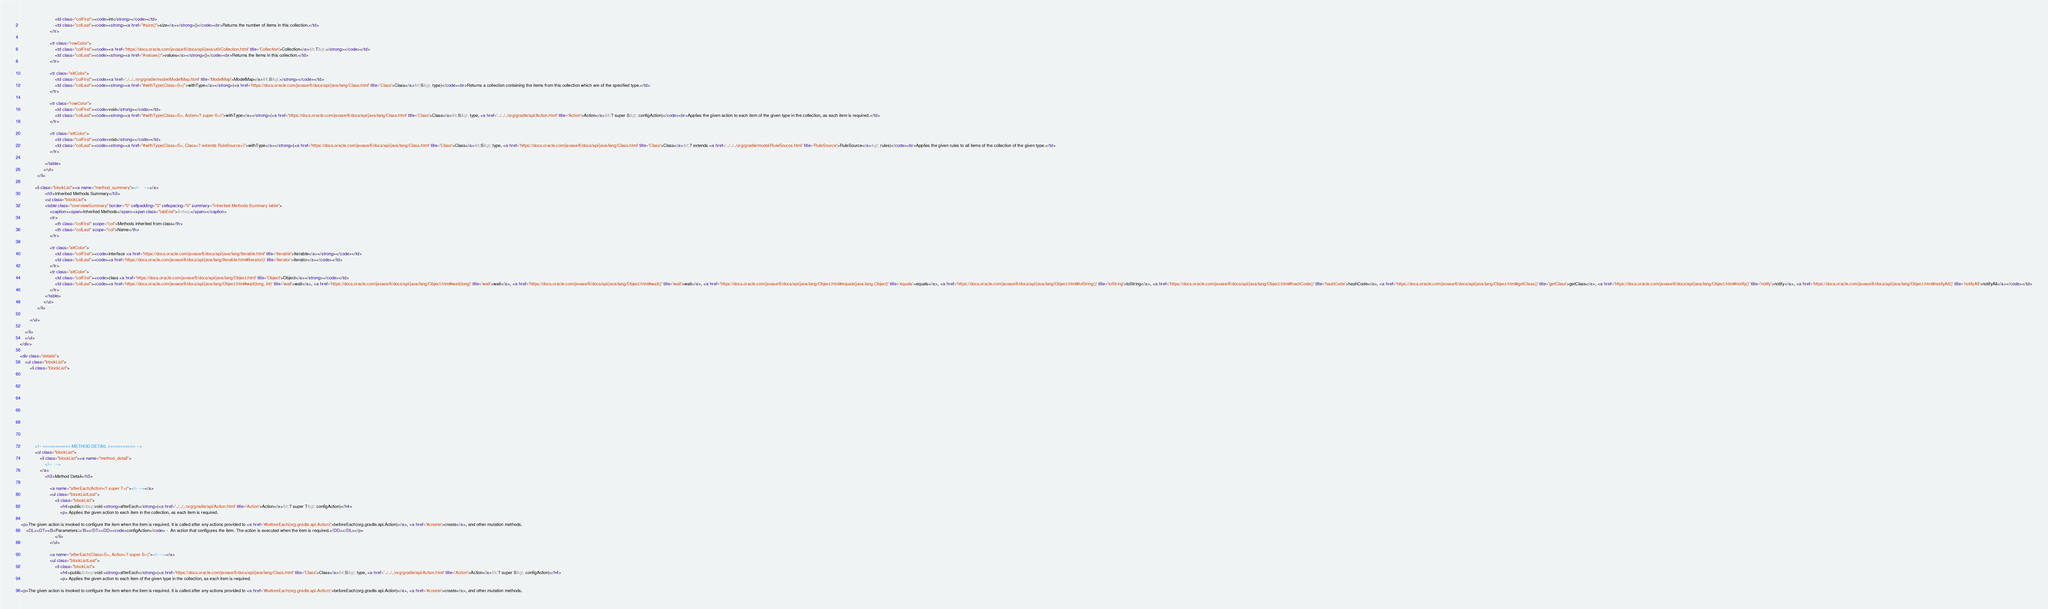<code> <loc_0><loc_0><loc_500><loc_500><_HTML_>                            <td class="colFirst"><code>int</strong></code></td>
                            <td class="colLast"><code><strong><a href="#size()">size</a></strong>()</code><br>Returns the number of items in this collection.</td>
                        </tr>
                        
                        <tr class="rowColor">
                            <td class="colFirst"><code><a href='https://docs.oracle.com/javase/6/docs/api/java/util/Collection.html' title='Collection'>Collection</a>&lt;T&gt;</strong></code></td>
                            <td class="colLast"><code><strong><a href="#values()">values</a></strong>()</code><br>Returns the items in this collection.</td>
                        </tr>
                        
                        <tr class="altColor">
                            <td class="colFirst"><code><a href='../../../org/gradle/model/ModelMap.html' title='ModelMap'>ModelMap</a>&lt;S&gt;</strong></code></td>
                            <td class="colLast"><code><strong><a href="#withType(Class<S>)">withType</a></strong>(<a href='https://docs.oracle.com/javase/6/docs/api/java/lang/Class.html' title='Class'>Class</a>&lt;S&gt; type)</code><br>Returns a collection containing the items from this collection which are of the specified type.</td>
                        </tr>
                        
                        <tr class="rowColor">
                            <td class="colFirst"><code>void</strong></code></td>
                            <td class="colLast"><code><strong><a href="#withType(Class<S>, Action<? super S>)">withType</a></strong>(<a href='https://docs.oracle.com/javase/6/docs/api/java/lang/Class.html' title='Class'>Class</a>&lt;S&gt; type, <a href='../../../org/gradle/api/Action.html' title='Action'>Action</a>&lt;? super S&gt; configAction)</code><br>Applies the given action to each item of the given type in the collection, as each item is required.</td>
                        </tr>
                        
                        <tr class="altColor">
                            <td class="colFirst"><code>void</strong></code></td>
                            <td class="colLast"><code><strong><a href="#withType(Class<S>, Class<? extends RuleSource>)">withType</a></strong>(<a href='https://docs.oracle.com/javase/6/docs/api/java/lang/Class.html' title='Class'>Class</a>&lt;S&gt; type, <a href='https://docs.oracle.com/javase/6/docs/api/java/lang/Class.html' title='Class'>Class</a>&lt;? extends <a href='../../../org/gradle/model/RuleSource.html' title='RuleSource'>RuleSource</a>&gt; rules)</code><br>Applies the given rules to all items of the collection of the given type.</td>
                        </tr>
                        
                    </table>
                   </ul>
              </li>
            
            <li class="blockList"><a name="method_summary"><!--   --></a>
                    <h3>Inherited Methods Summary</h3>
                    <ul class="blockList">
                    <table class="overviewSummary" border="0" cellpadding="3" cellspacing="0" summary="Inherited Methods Summary table">
                        <caption><span>Inherited Methods</span><span class="tabEnd">&nbsp;</span></caption>
                        <tr>
                            <th class="colFirst" scope="col">Methods inherited from class</th>
                            <th class="colLast" scope="col">Name</th>
                        </tr>
                        
                        <tr class="altColor">
                            <td class="colFirst"><code>interface <a href='https://docs.oracle.com/javase/6/docs/api/java/lang/Iterable.html' title='Iterable'>Iterable</a></strong></code></td>
                            <td class="colLast"><code><a href='https://docs.oracle.com/javase/6/docs/api/java/lang/Iterable.html#iterator()' title='iterator'>iterator</a></code></td>
                        </tr>
                        <tr class="altColor">
                            <td class="colFirst"><code>class <a href='https://docs.oracle.com/javase/6/docs/api/java/lang/Object.html' title='Object'>Object</a></strong></code></td>
                            <td class="colLast"><code><a href='https://docs.oracle.com/javase/6/docs/api/java/lang/Object.html#wait(long, int)' title='wait'>wait</a>, <a href='https://docs.oracle.com/javase/6/docs/api/java/lang/Object.html#wait(long)' title='wait'>wait</a>, <a href='https://docs.oracle.com/javase/6/docs/api/java/lang/Object.html#wait()' title='wait'>wait</a>, <a href='https://docs.oracle.com/javase/6/docs/api/java/lang/Object.html#equals(java.lang.Object)' title='equals'>equals</a>, <a href='https://docs.oracle.com/javase/6/docs/api/java/lang/Object.html#toString()' title='toString'>toString</a>, <a href='https://docs.oracle.com/javase/6/docs/api/java/lang/Object.html#hashCode()' title='hashCode'>hashCode</a>, <a href='https://docs.oracle.com/javase/6/docs/api/java/lang/Object.html#getClass()' title='getClass'>getClass</a>, <a href='https://docs.oracle.com/javase/6/docs/api/java/lang/Object.html#notify()' title='notify'>notify</a>, <a href='https://docs.oracle.com/javase/6/docs/api/java/lang/Object.html#notifyAll()' title='notifyAll'>notifyAll</a></code></td>
                        </tr>
                    </table>
                   </ul>
              </li>
                
        </ul>
        
    </li>
    </ul>
</div>

<div class="details">
    <ul class="blockList">
        <li class="blockList">
           

            

            

            

            


            
            <!-- =========== METHOD DETAIL =========== -->
            <ul class="blockList">
                <li class="blockList"><a name="method_detail">
                    <!--   -->
                </a>
                    <h3>Method Detail</h3>
                    
                        <a name="afterEach(Action<? super T>)"><!-- --></a>
                        <ul class="blockListLast">
                            <li class="blockList">
                                <h4>public&nbsp;void <strong>afterEach</strong>(<a href='../../../org/gradle/api/Action.html' title='Action'>Action</a>&lt;? super T&gt; configAction)</h4>
                                <p> Applies the given action to each item in the collection, as each item is required.

 <p>The given action is invoked to configure the item when the item is required. It is called after any actions provided to <a href='#beforeEach(org.gradle.api.Action)'>beforeEach(org.gradle.api.Action)</a>, <a href='#create'>create</a>, and other mutation methods.
     <DL><DT><B>Parameters:</B></DT><DD><code>configAction</code> -  An action that configures the item. The action is executed when the item is required.</DD></DL></p>
                            </li>
                        </ul>
                    
                        <a name="afterEach(Class<S>, Action<? super S>)"><!-- --></a>
                        <ul class="blockListLast">
                            <li class="blockList">
                                <h4>public&nbsp;void <strong>afterEach</strong>(<a href='https://docs.oracle.com/javase/6/docs/api/java/lang/Class.html' title='Class'>Class</a>&lt;S&gt; type, <a href='../../../org/gradle/api/Action.html' title='Action'>Action</a>&lt;? super S&gt; configAction)</h4>
                                <p> Applies the given action to each item of the given type in the collection, as each item is required.

 <p>The given action is invoked to configure the item when the item is required. It is called after any actions provided to <a href='#beforeEach(org.gradle.api.Action)'>beforeEach(org.gradle.api.Action)</a>, <a href='#create'>create</a>, and other mutation methods.</code> 